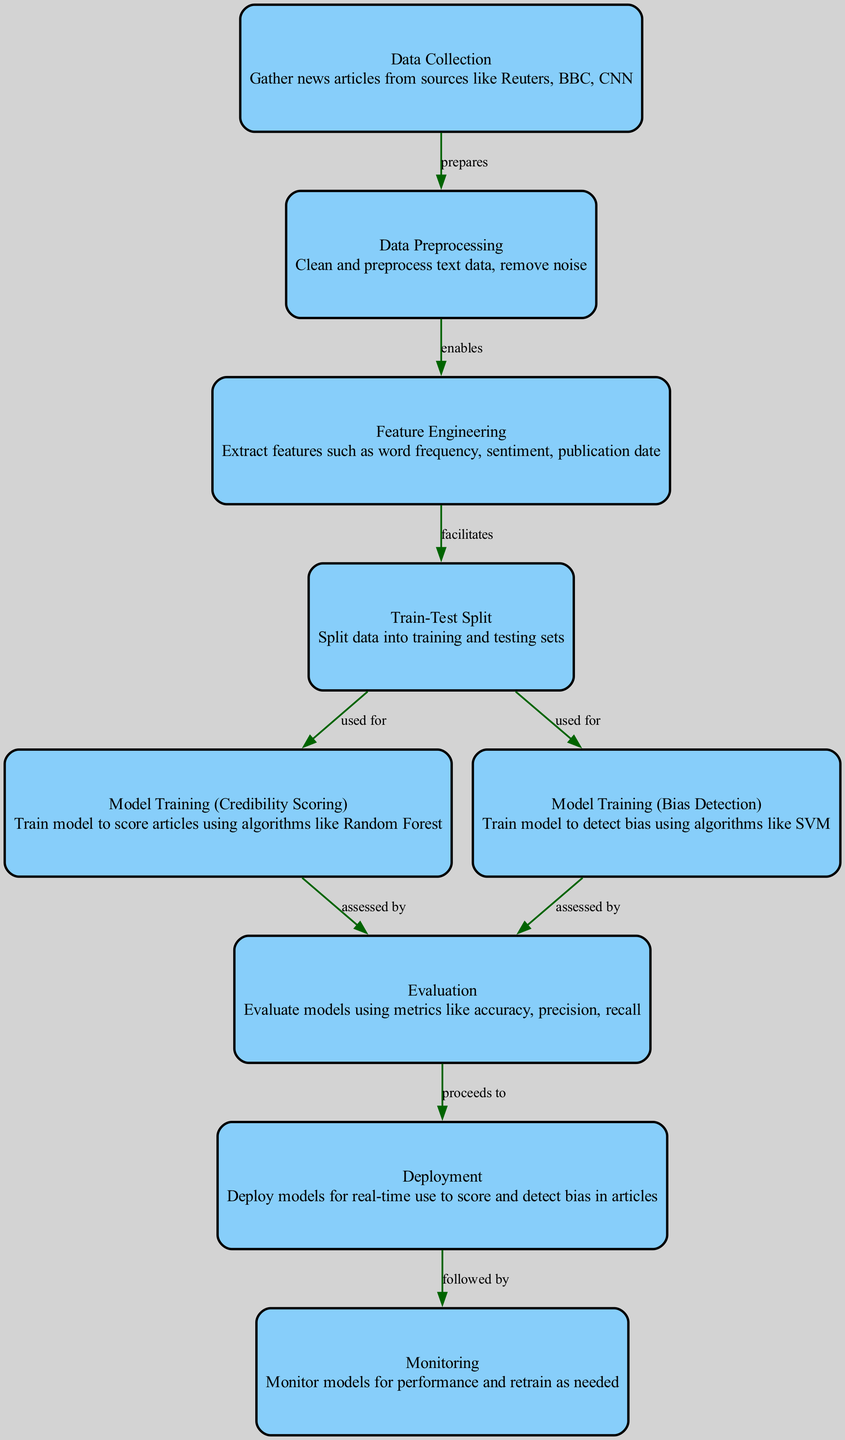What is the first step in the process? The first step is "Data Collection", which involves gathering news articles from sources like Reuters, BBC, and CNN. This node is positioned at the top of the diagram and initiates the process flow.
Answer: Data Collection How many nodes are there in the diagram? By counting the visual representation of each unique element in the diagram, we can see there are a total of nine distinct nodes detailing the machine learning process.
Answer: 9 Which node precedes "Model Training (Credibility Scoring)"? The "Train-Test Split" node directly precedes the "Model Training (Credibility Scoring)" node, as indicated by the flow of arrows connecting them sequentially.
Answer: Train-Test Split What type of model is trained for detecting bias? The model used for detecting bias is trained using the Support Vector Machine (SVM) algorithm, as indicated in the "Model Training (Bias Detection)" node.
Answer: SVM What comes after evaluation in the diagram? After evaluation, the process proceeds to the "Deployment" node, which signifies that the models are now put to use for real-time scoring and bias detection.
Answer: Deployment How many edges are there connecting the nodes? To find the number of edges, we examine the connections in the diagram, which amount to a total of eight directed edges linking the various nodes together.
Answer: 8 Which node is monitored after deployment? The "Monitoring" node is monitored after deployment, as it follows the deployment step to oversee models' performance and indicate if retraining is necessary.
Answer: Monitoring What does feature engineering involve? Feature engineering involves extracting various features, including word frequency, sentiment, and publication date, as specified in the "Feature Engineering" node of the diagram.
Answer: Extracting features What happens to the model after assessment? After assessment in the evaluation node, the model is then deployed for real-time use as indicated in the subsequent connection to the deployment node.
Answer: Deployment 